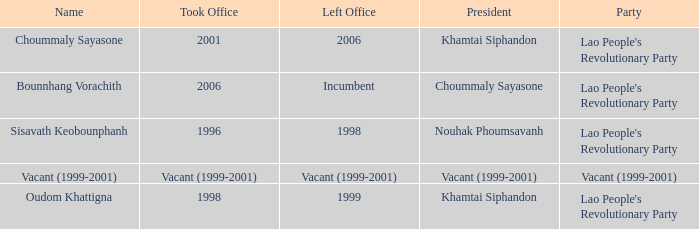What is Party, when Took Office is 1998? Lao People's Revolutionary Party. 